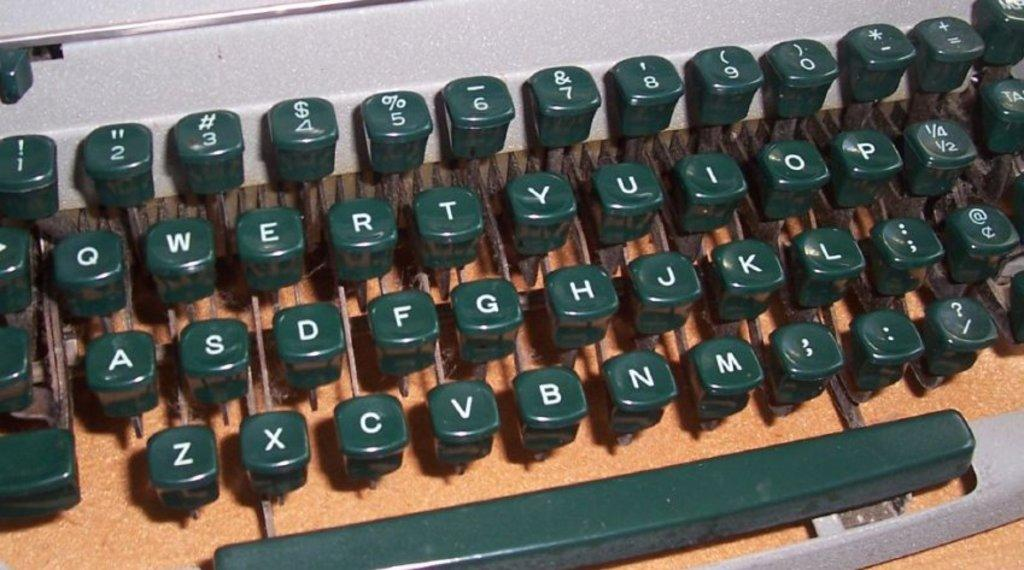Provide a one-sentence caption for the provided image. A typewriter keyboard with the letters of the alphabet on it. 